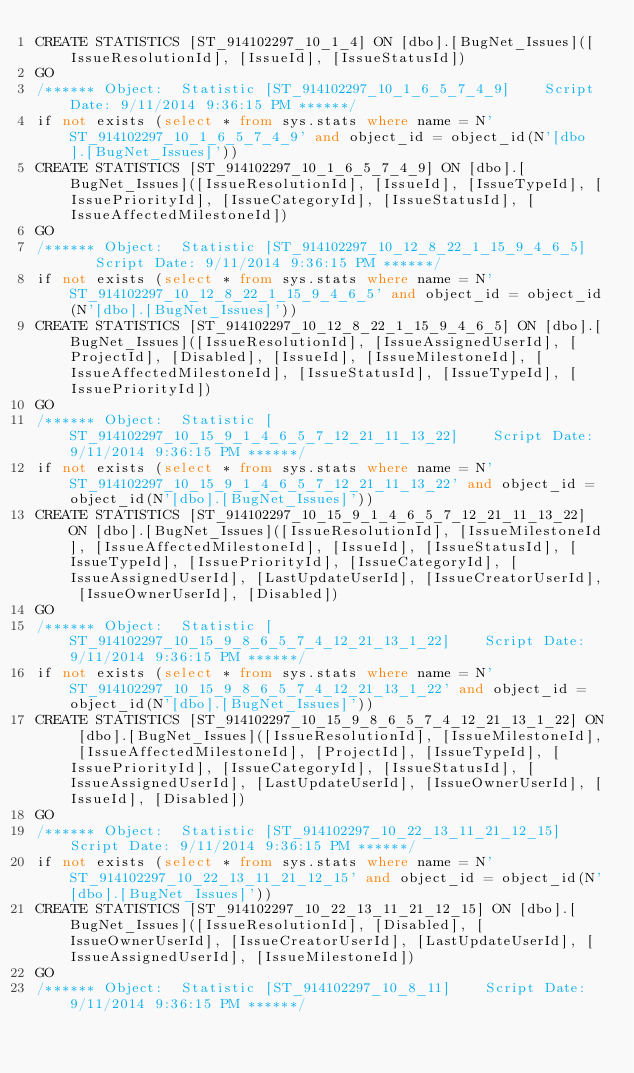Convert code to text. <code><loc_0><loc_0><loc_500><loc_500><_SQL_>CREATE STATISTICS [ST_914102297_10_1_4] ON [dbo].[BugNet_Issues]([IssueResolutionId], [IssueId], [IssueStatusId])
GO
/****** Object:  Statistic [ST_914102297_10_1_6_5_7_4_9]    Script Date: 9/11/2014 9:36:15 PM ******/
if not exists (select * from sys.stats where name = N'ST_914102297_10_1_6_5_7_4_9' and object_id = object_id(N'[dbo].[BugNet_Issues]'))
CREATE STATISTICS [ST_914102297_10_1_6_5_7_4_9] ON [dbo].[BugNet_Issues]([IssueResolutionId], [IssueId], [IssueTypeId], [IssuePriorityId], [IssueCategoryId], [IssueStatusId], [IssueAffectedMilestoneId])
GO
/****** Object:  Statistic [ST_914102297_10_12_8_22_1_15_9_4_6_5]    Script Date: 9/11/2014 9:36:15 PM ******/
if not exists (select * from sys.stats where name = N'ST_914102297_10_12_8_22_1_15_9_4_6_5' and object_id = object_id(N'[dbo].[BugNet_Issues]'))
CREATE STATISTICS [ST_914102297_10_12_8_22_1_15_9_4_6_5] ON [dbo].[BugNet_Issues]([IssueResolutionId], [IssueAssignedUserId], [ProjectId], [Disabled], [IssueId], [IssueMilestoneId], [IssueAffectedMilestoneId], [IssueStatusId], [IssueTypeId], [IssuePriorityId])
GO
/****** Object:  Statistic [ST_914102297_10_15_9_1_4_6_5_7_12_21_11_13_22]    Script Date: 9/11/2014 9:36:15 PM ******/
if not exists (select * from sys.stats where name = N'ST_914102297_10_15_9_1_4_6_5_7_12_21_11_13_22' and object_id = object_id(N'[dbo].[BugNet_Issues]'))
CREATE STATISTICS [ST_914102297_10_15_9_1_4_6_5_7_12_21_11_13_22] ON [dbo].[BugNet_Issues]([IssueResolutionId], [IssueMilestoneId], [IssueAffectedMilestoneId], [IssueId], [IssueStatusId], [IssueTypeId], [IssuePriorityId], [IssueCategoryId], [IssueAssignedUserId], [LastUpdateUserId], [IssueCreatorUserId], [IssueOwnerUserId], [Disabled])
GO
/****** Object:  Statistic [ST_914102297_10_15_9_8_6_5_7_4_12_21_13_1_22]    Script Date: 9/11/2014 9:36:15 PM ******/
if not exists (select * from sys.stats where name = N'ST_914102297_10_15_9_8_6_5_7_4_12_21_13_1_22' and object_id = object_id(N'[dbo].[BugNet_Issues]'))
CREATE STATISTICS [ST_914102297_10_15_9_8_6_5_7_4_12_21_13_1_22] ON [dbo].[BugNet_Issues]([IssueResolutionId], [IssueMilestoneId], [IssueAffectedMilestoneId], [ProjectId], [IssueTypeId], [IssuePriorityId], [IssueCategoryId], [IssueStatusId], [IssueAssignedUserId], [LastUpdateUserId], [IssueOwnerUserId], [IssueId], [Disabled])
GO
/****** Object:  Statistic [ST_914102297_10_22_13_11_21_12_15]    Script Date: 9/11/2014 9:36:15 PM ******/
if not exists (select * from sys.stats where name = N'ST_914102297_10_22_13_11_21_12_15' and object_id = object_id(N'[dbo].[BugNet_Issues]'))
CREATE STATISTICS [ST_914102297_10_22_13_11_21_12_15] ON [dbo].[BugNet_Issues]([IssueResolutionId], [Disabled], [IssueOwnerUserId], [IssueCreatorUserId], [LastUpdateUserId], [IssueAssignedUserId], [IssueMilestoneId])
GO
/****** Object:  Statistic [ST_914102297_10_8_11]    Script Date: 9/11/2014 9:36:15 PM ******/</code> 